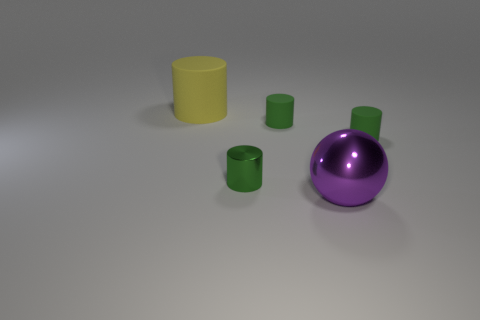Are the objects arranged in any particular pattern? The objects do not appear to be arranged in a specific pattern; they are placed randomly on a flat surface. 